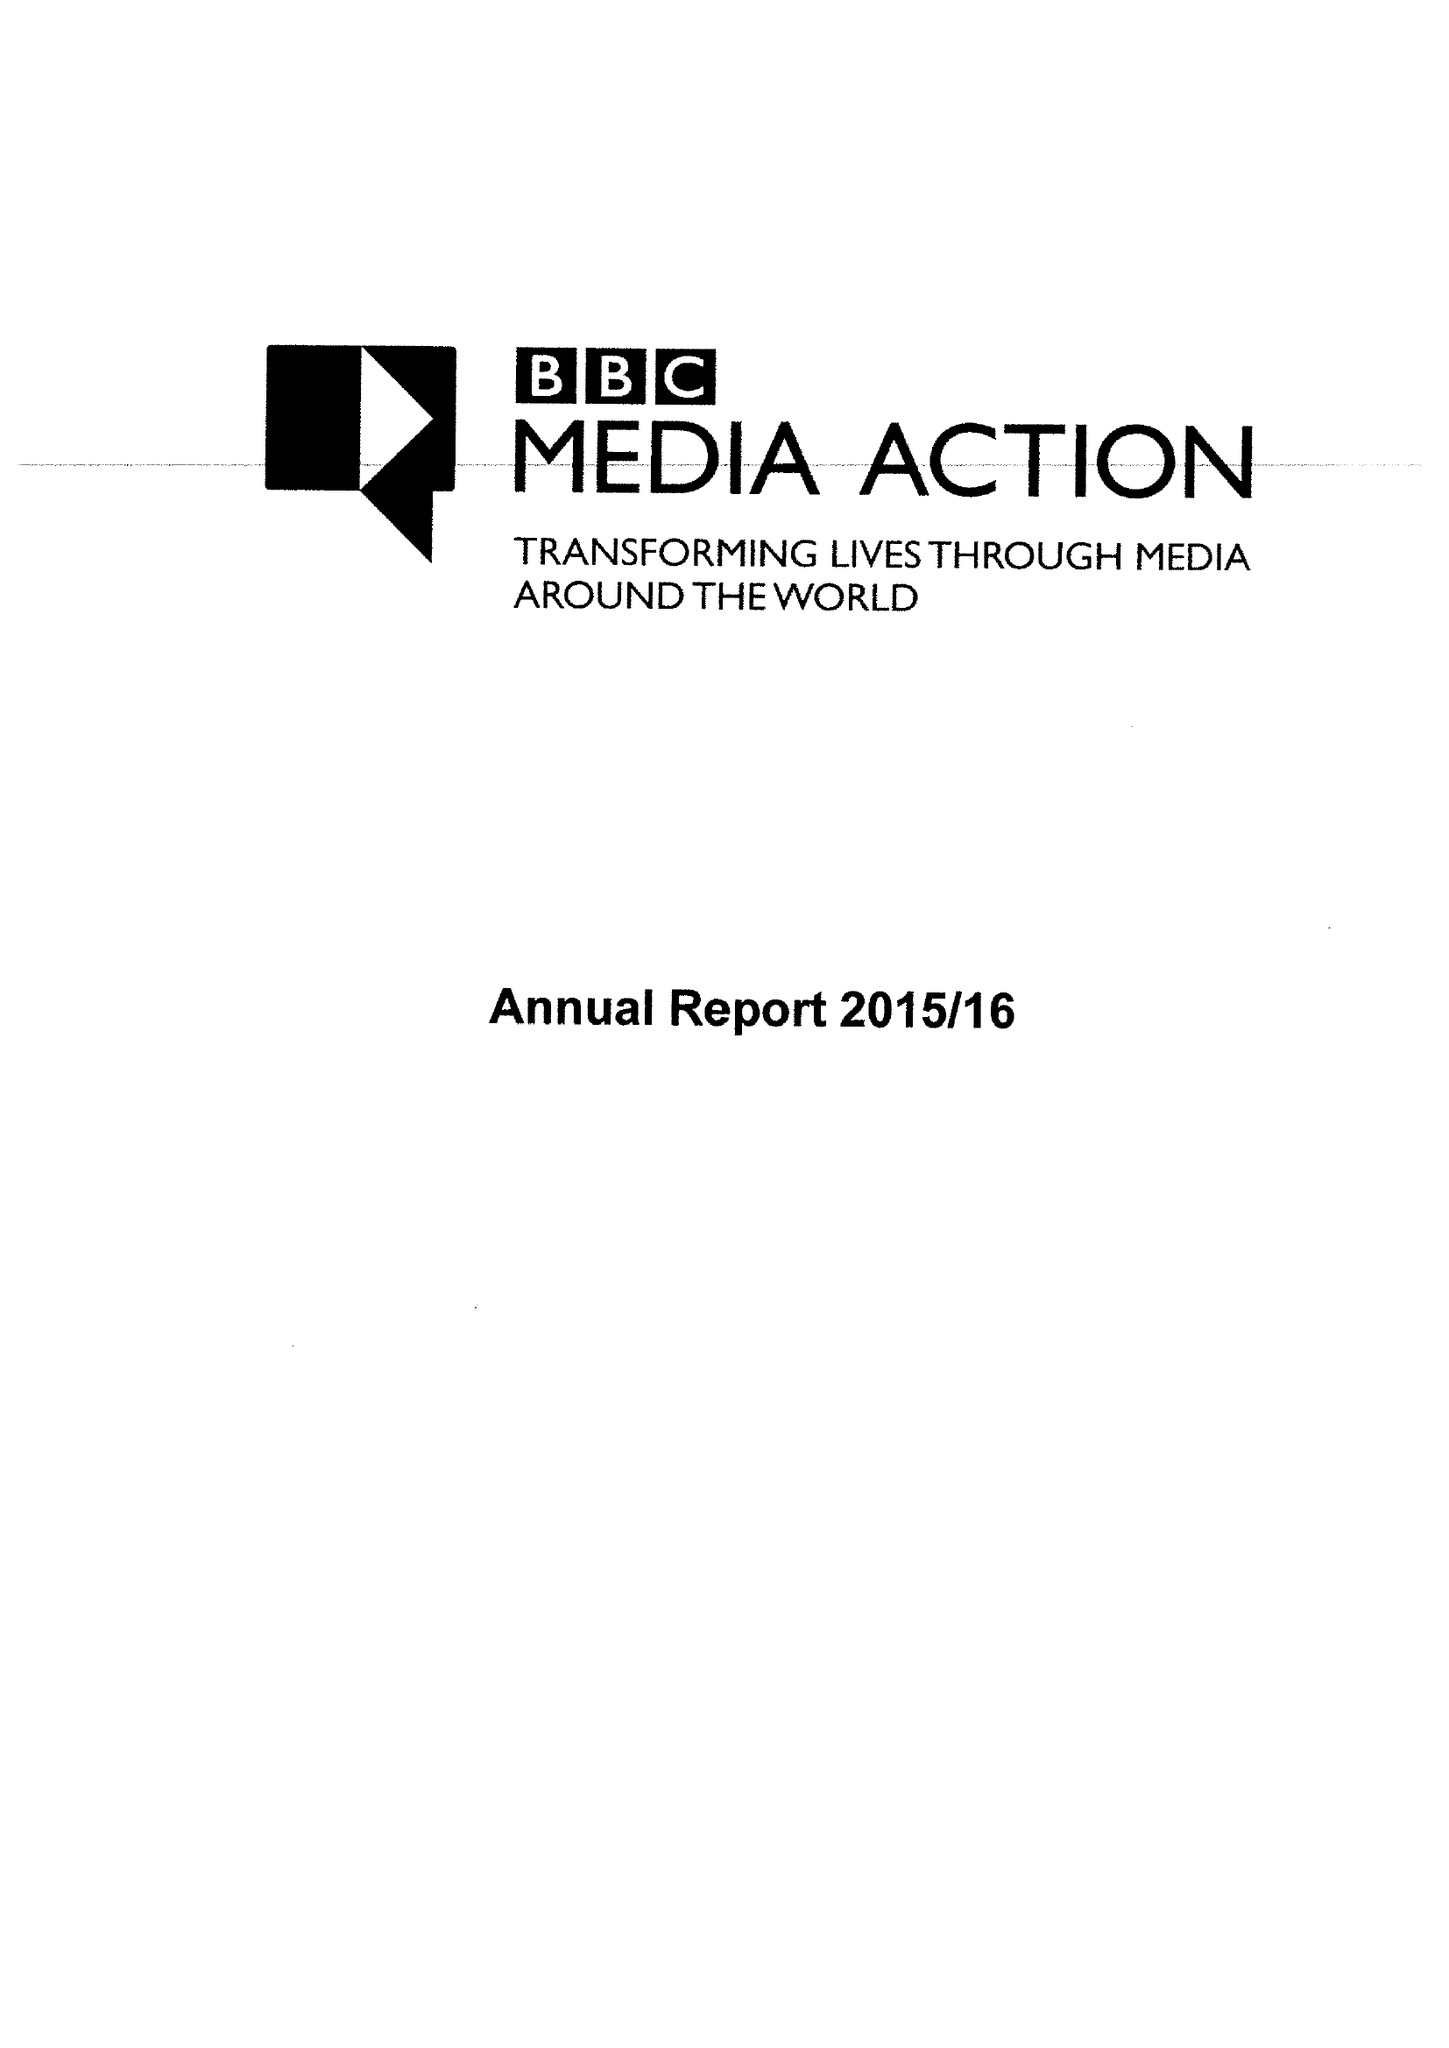What is the value for the income_annually_in_british_pounds?
Answer the question using a single word or phrase. 45278000.00 